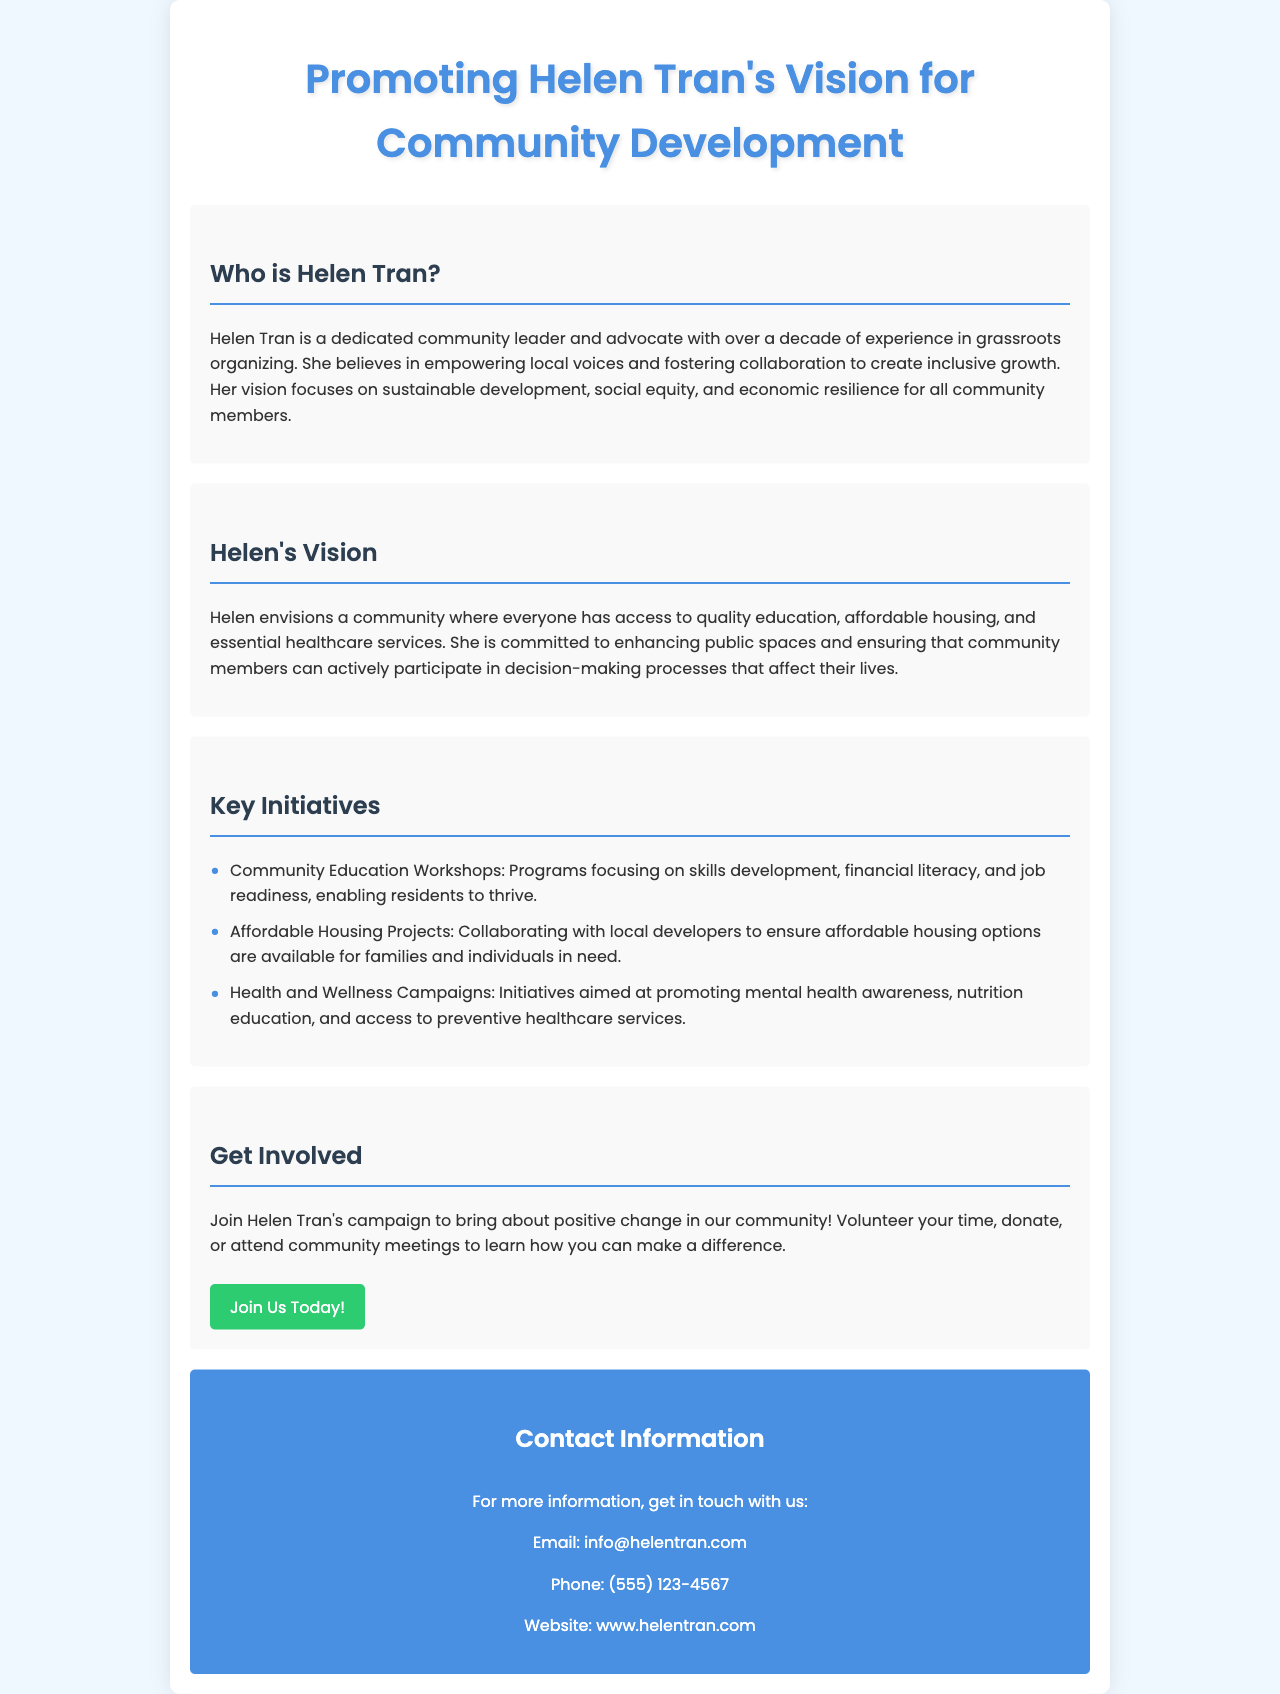What is Helen Tran's role? Helen Tran is described as a dedicated community leader and advocate, emphasizing her leadership role in the community.
Answer: Community leader What are the key focuses of Helen's vision? The document outlines that Helen's vision focuses on sustainable development, social equity, and economic resilience for community members.
Answer: Sustainable development, social equity, economic resilience How many years of experience does Helen Tran have in grassroots organizing? The document states that Helen has over a decade of experience.
Answer: Over a decade What initiative aims to promote mental health awareness? One of the key initiatives mentioned is focused on promoting mental health awareness among community members.
Answer: Health and Wellness Campaigns What can individuals do to support Helen Tran's campaign? The brochure suggests several actions such as volunteering time, donating, or attending community meetings to support her campaign.
Answer: Volunteer, donate, attend meetings What type of education programs does Helen’s campaign include? The document mentions community education workshops designed for skills development and financial literacy.
Answer: Community Education Workshops What is the contact email provided for more information? The document directly provides an email address for further contact related to Helen Tran's campaign.
Answer: info@helentran.com What is the background color of the brochure? The brochure's background color is specified in the design as light blue, which is appealing and easy to read.
Answer: Light blue 